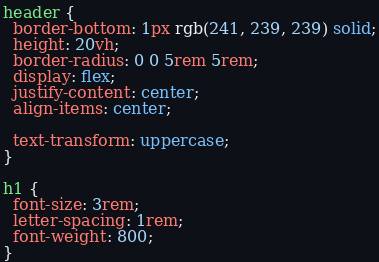Convert code to text. <code><loc_0><loc_0><loc_500><loc_500><_CSS_>header {
  border-bottom: 1px rgb(241, 239, 239) solid;
  height: 20vh;
  border-radius: 0 0 5rem 5rem;
  display: flex;
  justify-content: center;
  align-items: center;

  text-transform: uppercase;
}

h1 {
  font-size: 3rem;
  letter-spacing: 1rem;
  font-weight: 800;
}
</code> 